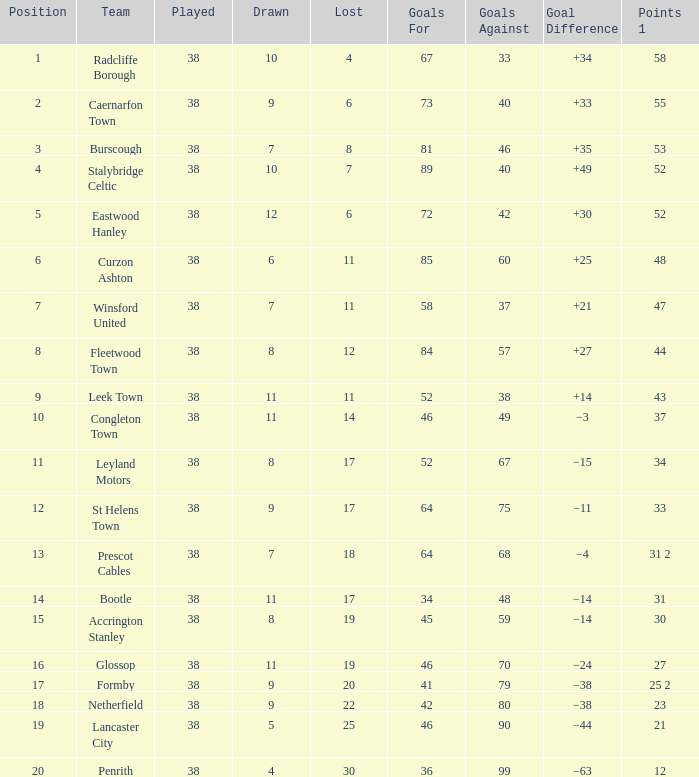WHAT IS THE POSITION WITH A LOST OF 6, FOR CAERNARFON TOWN? 2.0. Would you mind parsing the complete table? {'header': ['Position', 'Team', 'Played', 'Drawn', 'Lost', 'Goals For', 'Goals Against', 'Goal Difference', 'Points 1'], 'rows': [['1', 'Radcliffe Borough', '38', '10', '4', '67', '33', '+34', '58'], ['2', 'Caernarfon Town', '38', '9', '6', '73', '40', '+33', '55'], ['3', 'Burscough', '38', '7', '8', '81', '46', '+35', '53'], ['4', 'Stalybridge Celtic', '38', '10', '7', '89', '40', '+49', '52'], ['5', 'Eastwood Hanley', '38', '12', '6', '72', '42', '+30', '52'], ['6', 'Curzon Ashton', '38', '6', '11', '85', '60', '+25', '48'], ['7', 'Winsford United', '38', '7', '11', '58', '37', '+21', '47'], ['8', 'Fleetwood Town', '38', '8', '12', '84', '57', '+27', '44'], ['9', 'Leek Town', '38', '11', '11', '52', '38', '+14', '43'], ['10', 'Congleton Town', '38', '11', '14', '46', '49', '−3', '37'], ['11', 'Leyland Motors', '38', '8', '17', '52', '67', '−15', '34'], ['12', 'St Helens Town', '38', '9', '17', '64', '75', '−11', '33'], ['13', 'Prescot Cables', '38', '7', '18', '64', '68', '−4', '31 2'], ['14', 'Bootle', '38', '11', '17', '34', '48', '−14', '31'], ['15', 'Accrington Stanley', '38', '8', '19', '45', '59', '−14', '30'], ['16', 'Glossop', '38', '11', '19', '46', '70', '−24', '27'], ['17', 'Formby', '38', '9', '20', '41', '79', '−38', '25 2'], ['18', 'Netherfield', '38', '9', '22', '42', '80', '−38', '23'], ['19', 'Lancaster City', '38', '5', '25', '46', '90', '−44', '21'], ['20', 'Penrith', '38', '4', '30', '36', '99', '−63', '12']]} 